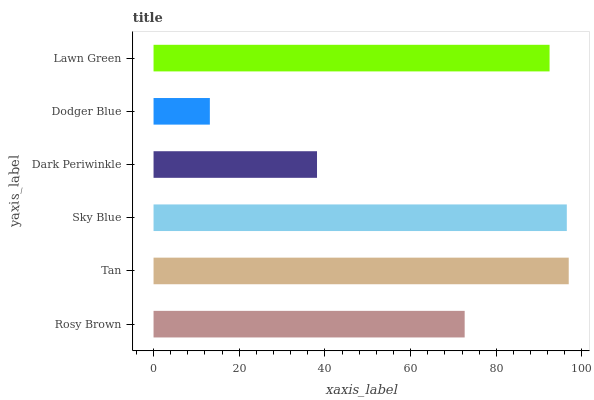Is Dodger Blue the minimum?
Answer yes or no. Yes. Is Tan the maximum?
Answer yes or no. Yes. Is Sky Blue the minimum?
Answer yes or no. No. Is Sky Blue the maximum?
Answer yes or no. No. Is Tan greater than Sky Blue?
Answer yes or no. Yes. Is Sky Blue less than Tan?
Answer yes or no. Yes. Is Sky Blue greater than Tan?
Answer yes or no. No. Is Tan less than Sky Blue?
Answer yes or no. No. Is Lawn Green the high median?
Answer yes or no. Yes. Is Rosy Brown the low median?
Answer yes or no. Yes. Is Dark Periwinkle the high median?
Answer yes or no. No. Is Sky Blue the low median?
Answer yes or no. No. 